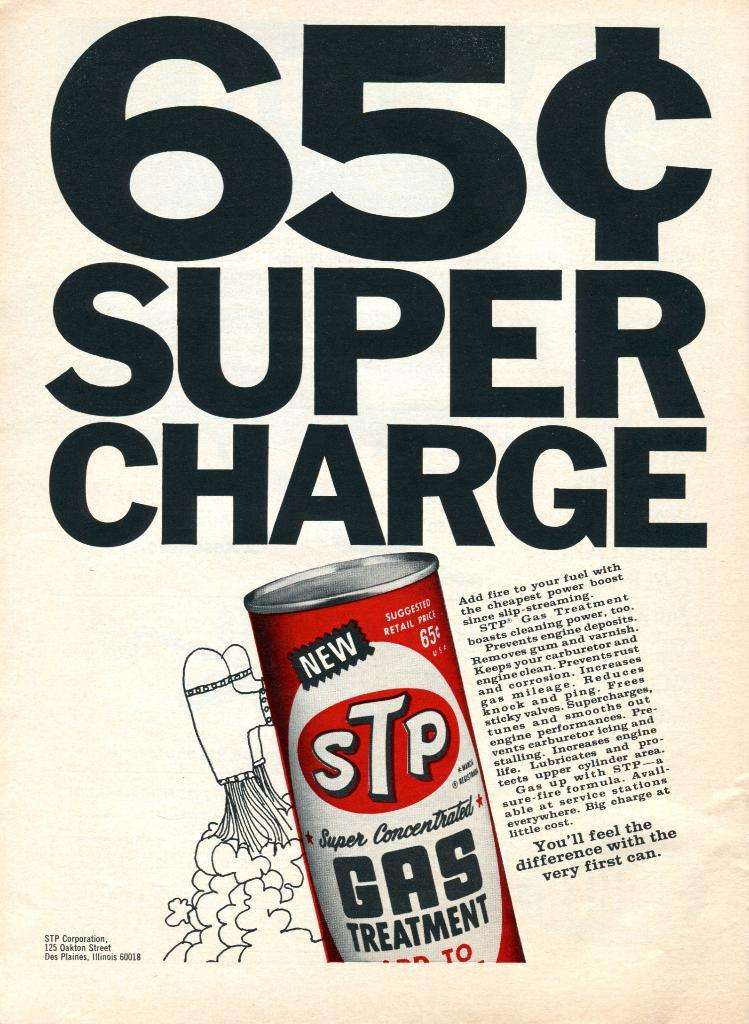Provide a one-sentence caption for the provided image. An advertisement displaying a 65 cent super charge. 